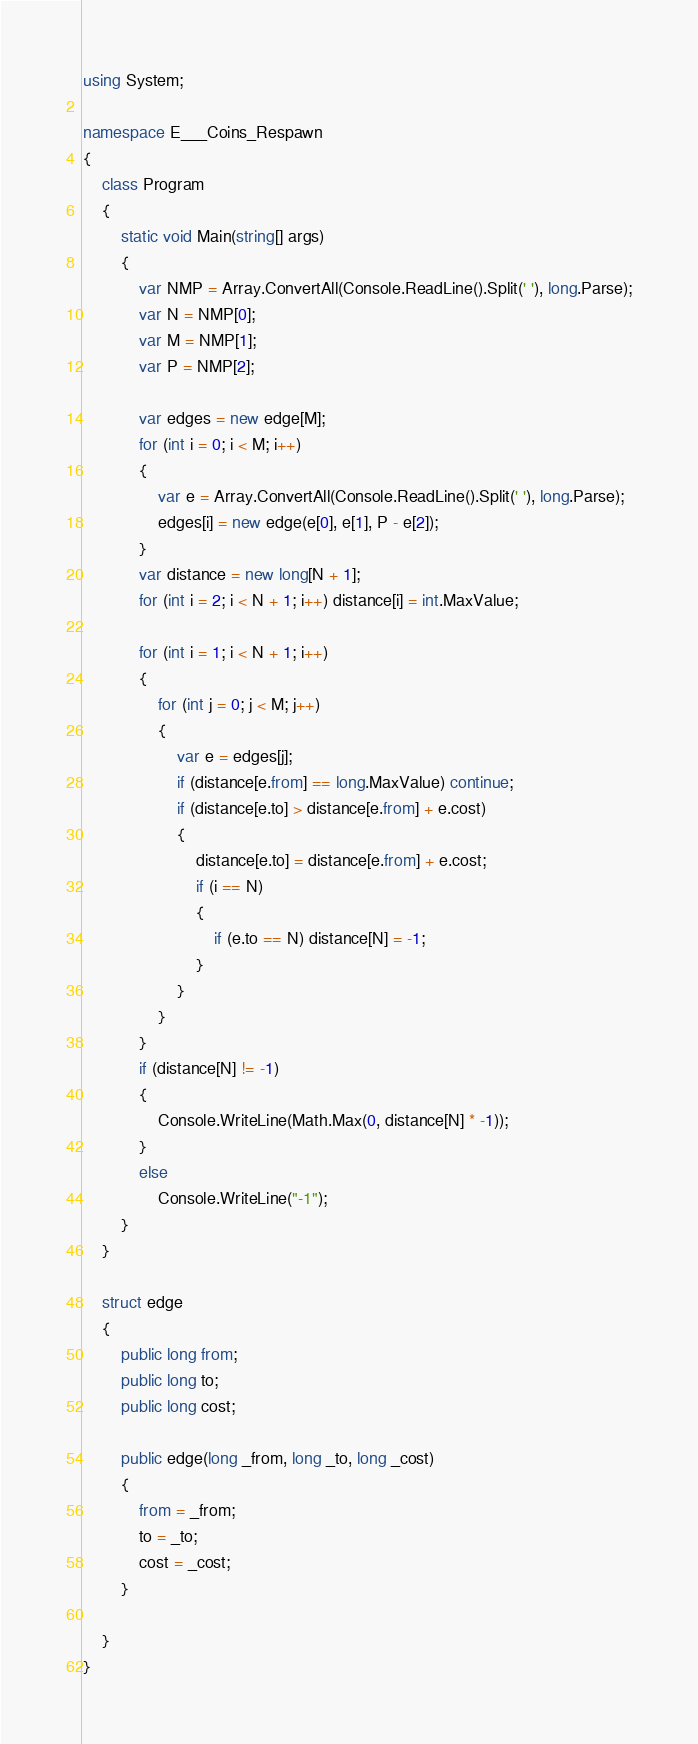Convert code to text. <code><loc_0><loc_0><loc_500><loc_500><_C#_>using System;

namespace E___Coins_Respawn
{
    class Program
    {
        static void Main(string[] args)
        {
            var NMP = Array.ConvertAll(Console.ReadLine().Split(' '), long.Parse);
            var N = NMP[0];
            var M = NMP[1];
            var P = NMP[2];

            var edges = new edge[M];
            for (int i = 0; i < M; i++)
            {
                var e = Array.ConvertAll(Console.ReadLine().Split(' '), long.Parse);
                edges[i] = new edge(e[0], e[1], P - e[2]);
            }
            var distance = new long[N + 1];
            for (int i = 2; i < N + 1; i++) distance[i] = int.MaxValue;

            for (int i = 1; i < N + 1; i++)
            {
                for (int j = 0; j < M; j++)
                {
                    var e = edges[j];
                    if (distance[e.from] == long.MaxValue) continue;
                    if (distance[e.to] > distance[e.from] + e.cost)
                    {
                        distance[e.to] = distance[e.from] + e.cost;
                        if (i == N)
                        {
                            if (e.to == N) distance[N] = -1;
                        }
                    }
                }
            }
            if (distance[N] != -1)
            {
                Console.WriteLine(Math.Max(0, distance[N] * -1));
            }
            else
                Console.WriteLine("-1");
        }
    }

    struct edge
    {
        public long from;
        public long to;
        public long cost;

        public edge(long _from, long _to, long _cost)
        {
            from = _from;
            to = _to;
            cost = _cost;
        }

    }
}
</code> 